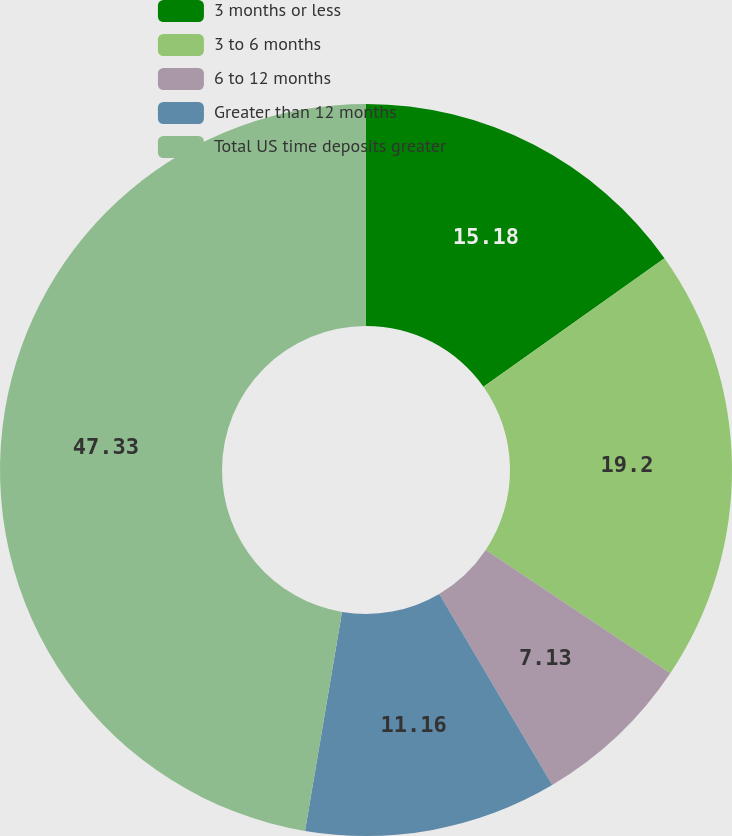<chart> <loc_0><loc_0><loc_500><loc_500><pie_chart><fcel>3 months or less<fcel>3 to 6 months<fcel>6 to 12 months<fcel>Greater than 12 months<fcel>Total US time deposits greater<nl><fcel>15.18%<fcel>19.2%<fcel>7.13%<fcel>11.16%<fcel>47.34%<nl></chart> 